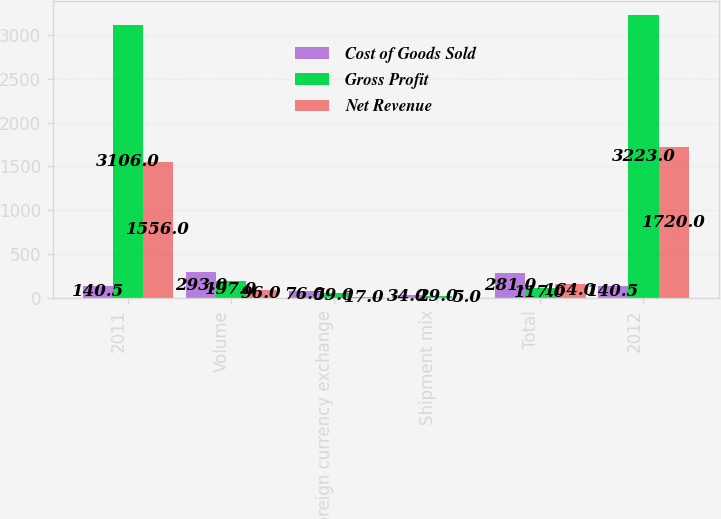Convert chart. <chart><loc_0><loc_0><loc_500><loc_500><stacked_bar_chart><ecel><fcel>2011<fcel>Volume<fcel>Foreign currency exchange<fcel>Shipment mix<fcel>Total<fcel>2012<nl><fcel>Cost of Goods Sold<fcel>140.5<fcel>293<fcel>76<fcel>34<fcel>281<fcel>140.5<nl><fcel>Gross Profit<fcel>3106<fcel>197<fcel>59<fcel>29<fcel>117<fcel>3223<nl><fcel>Net Revenue<fcel>1556<fcel>96<fcel>17<fcel>5<fcel>164<fcel>1720<nl></chart> 